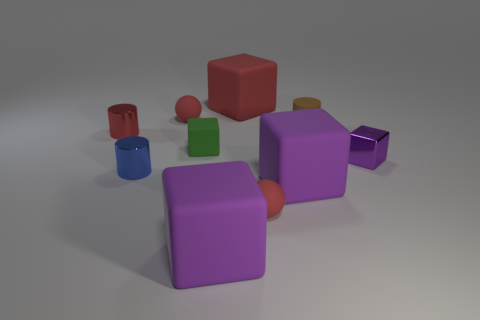How many other things are there of the same color as the small rubber cylinder?
Your answer should be very brief. 0. Do the matte cylinder and the tiny cylinder that is in front of the tiny green matte block have the same color?
Your answer should be compact. No. There is another tiny rubber thing that is the same shape as the tiny blue object; what is its color?
Provide a short and direct response. Brown. Do the tiny brown cylinder and the purple cube to the right of the small brown cylinder have the same material?
Provide a succinct answer. No. The tiny matte cylinder has what color?
Provide a succinct answer. Brown. There is a big object that is behind the purple shiny block that is in front of the large matte cube behind the small green object; what color is it?
Give a very brief answer. Red. Do the small red metallic thing and the big object that is behind the tiny brown cylinder have the same shape?
Keep it short and to the point. No. The small metal thing that is both on the left side of the tiny purple cube and behind the blue metallic thing is what color?
Your answer should be very brief. Red. Is there a small yellow metallic object that has the same shape as the tiny brown rubber thing?
Make the answer very short. No. Does the rubber cylinder have the same color as the small shiny block?
Your answer should be very brief. No. 